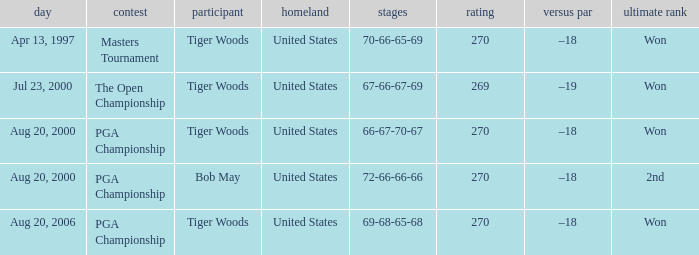What players finished 2nd? Bob May. 